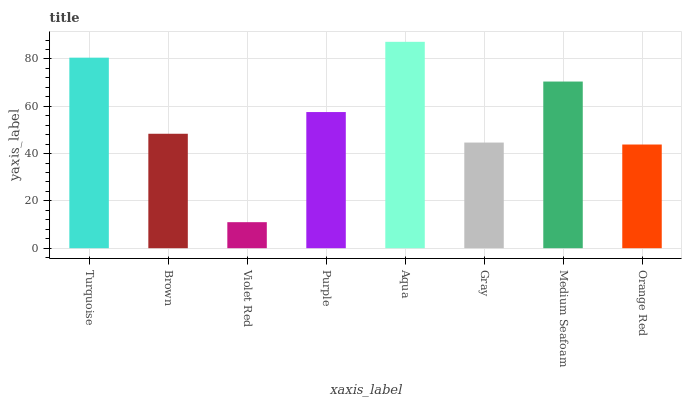Is Violet Red the minimum?
Answer yes or no. Yes. Is Aqua the maximum?
Answer yes or no. Yes. Is Brown the minimum?
Answer yes or no. No. Is Brown the maximum?
Answer yes or no. No. Is Turquoise greater than Brown?
Answer yes or no. Yes. Is Brown less than Turquoise?
Answer yes or no. Yes. Is Brown greater than Turquoise?
Answer yes or no. No. Is Turquoise less than Brown?
Answer yes or no. No. Is Purple the high median?
Answer yes or no. Yes. Is Brown the low median?
Answer yes or no. Yes. Is Turquoise the high median?
Answer yes or no. No. Is Aqua the low median?
Answer yes or no. No. 